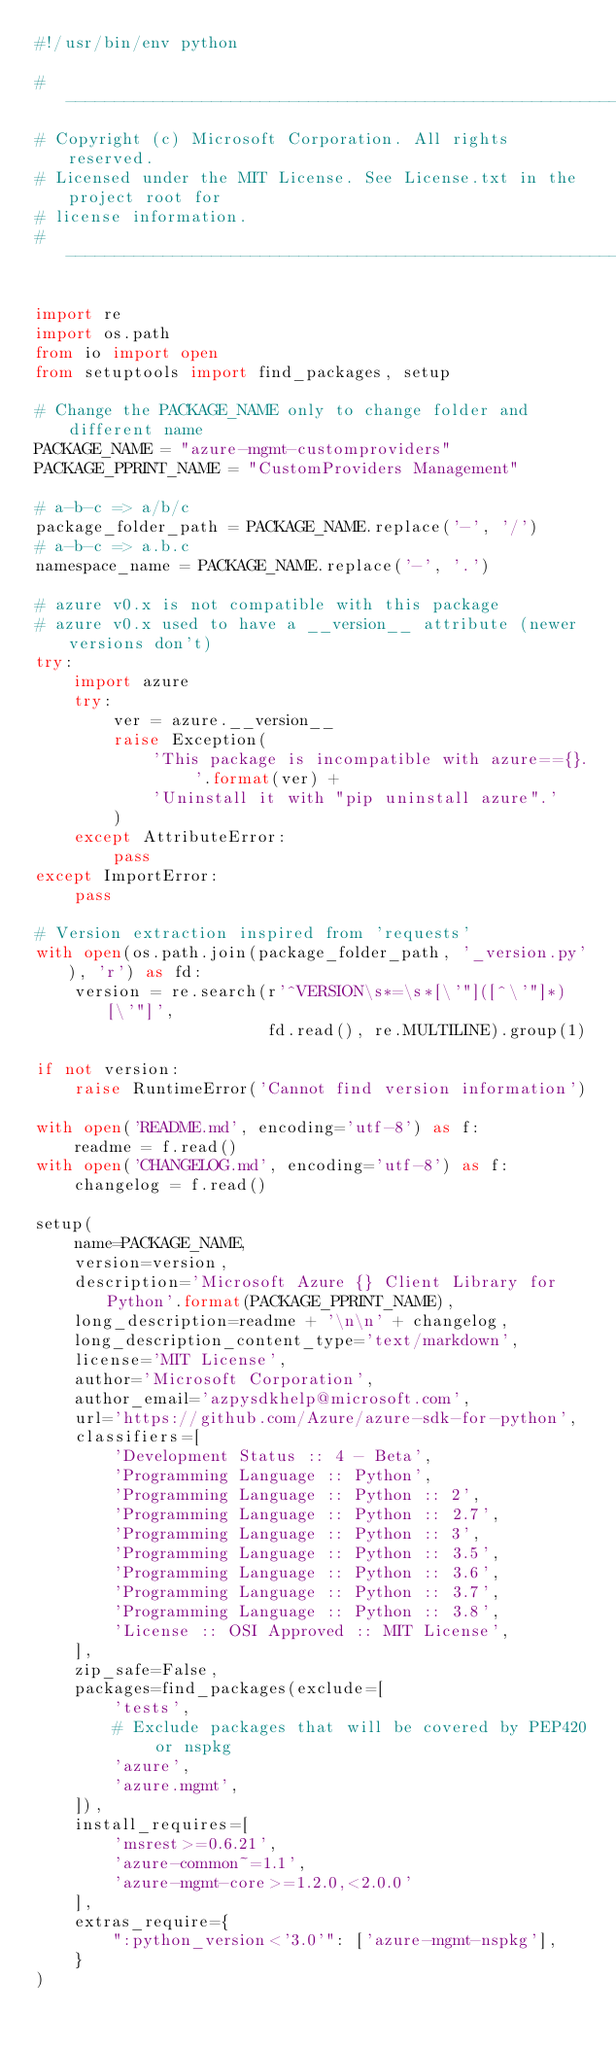Convert code to text. <code><loc_0><loc_0><loc_500><loc_500><_Python_>#!/usr/bin/env python

#-------------------------------------------------------------------------
# Copyright (c) Microsoft Corporation. All rights reserved.
# Licensed under the MIT License. See License.txt in the project root for
# license information.
#--------------------------------------------------------------------------

import re
import os.path
from io import open
from setuptools import find_packages, setup

# Change the PACKAGE_NAME only to change folder and different name
PACKAGE_NAME = "azure-mgmt-customproviders"
PACKAGE_PPRINT_NAME = "CustomProviders Management"

# a-b-c => a/b/c
package_folder_path = PACKAGE_NAME.replace('-', '/')
# a-b-c => a.b.c
namespace_name = PACKAGE_NAME.replace('-', '.')

# azure v0.x is not compatible with this package
# azure v0.x used to have a __version__ attribute (newer versions don't)
try:
    import azure
    try:
        ver = azure.__version__
        raise Exception(
            'This package is incompatible with azure=={}. '.format(ver) +
            'Uninstall it with "pip uninstall azure".'
        )
    except AttributeError:
        pass
except ImportError:
    pass

# Version extraction inspired from 'requests'
with open(os.path.join(package_folder_path, '_version.py'), 'r') as fd:
    version = re.search(r'^VERSION\s*=\s*[\'"]([^\'"]*)[\'"]',
                        fd.read(), re.MULTILINE).group(1)

if not version:
    raise RuntimeError('Cannot find version information')

with open('README.md', encoding='utf-8') as f:
    readme = f.read()
with open('CHANGELOG.md', encoding='utf-8') as f:
    changelog = f.read()

setup(
    name=PACKAGE_NAME,
    version=version,
    description='Microsoft Azure {} Client Library for Python'.format(PACKAGE_PPRINT_NAME),
    long_description=readme + '\n\n' + changelog,
    long_description_content_type='text/markdown',
    license='MIT License',
    author='Microsoft Corporation',
    author_email='azpysdkhelp@microsoft.com',
    url='https://github.com/Azure/azure-sdk-for-python',
    classifiers=[
        'Development Status :: 4 - Beta',
        'Programming Language :: Python',
        'Programming Language :: Python :: 2',
        'Programming Language :: Python :: 2.7',
        'Programming Language :: Python :: 3',
        'Programming Language :: Python :: 3.5',
        'Programming Language :: Python :: 3.6',
        'Programming Language :: Python :: 3.7',
        'Programming Language :: Python :: 3.8',
        'License :: OSI Approved :: MIT License',
    ],
    zip_safe=False,
    packages=find_packages(exclude=[
        'tests',
        # Exclude packages that will be covered by PEP420 or nspkg
        'azure',
        'azure.mgmt',
    ]),
    install_requires=[
        'msrest>=0.6.21',
        'azure-common~=1.1',
        'azure-mgmt-core>=1.2.0,<2.0.0'
    ],
    extras_require={
        ":python_version<'3.0'": ['azure-mgmt-nspkg'],
    }
)
</code> 